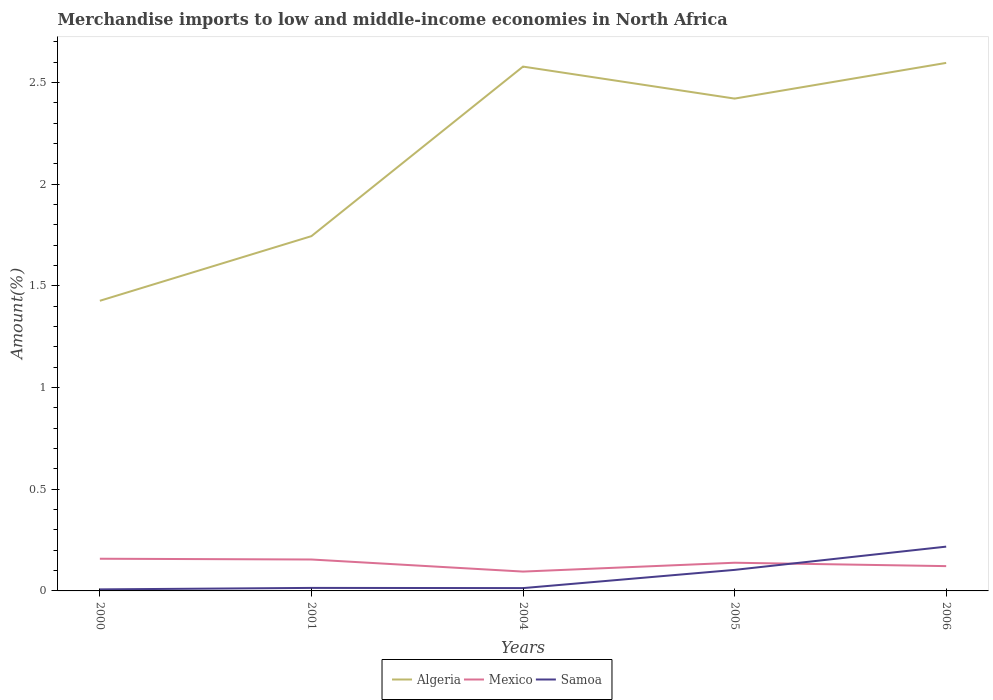Across all years, what is the maximum percentage of amount earned from merchandise imports in Samoa?
Keep it short and to the point. 0.01. In which year was the percentage of amount earned from merchandise imports in Algeria maximum?
Ensure brevity in your answer.  2000. What is the total percentage of amount earned from merchandise imports in Mexico in the graph?
Your answer should be very brief. 0.03. What is the difference between the highest and the second highest percentage of amount earned from merchandise imports in Algeria?
Provide a succinct answer. 1.17. What is the difference between the highest and the lowest percentage of amount earned from merchandise imports in Samoa?
Provide a succinct answer. 2. Is the percentage of amount earned from merchandise imports in Mexico strictly greater than the percentage of amount earned from merchandise imports in Algeria over the years?
Offer a terse response. Yes. How many lines are there?
Your answer should be compact. 3. How many years are there in the graph?
Provide a short and direct response. 5. Are the values on the major ticks of Y-axis written in scientific E-notation?
Your answer should be very brief. No. Does the graph contain any zero values?
Provide a short and direct response. No. How are the legend labels stacked?
Keep it short and to the point. Horizontal. What is the title of the graph?
Your answer should be compact. Merchandise imports to low and middle-income economies in North Africa. What is the label or title of the Y-axis?
Provide a succinct answer. Amount(%). What is the Amount(%) of Algeria in 2000?
Offer a very short reply. 1.43. What is the Amount(%) in Mexico in 2000?
Your response must be concise. 0.16. What is the Amount(%) of Samoa in 2000?
Make the answer very short. 0.01. What is the Amount(%) of Algeria in 2001?
Provide a succinct answer. 1.74. What is the Amount(%) in Mexico in 2001?
Give a very brief answer. 0.15. What is the Amount(%) of Samoa in 2001?
Keep it short and to the point. 0.01. What is the Amount(%) in Algeria in 2004?
Provide a short and direct response. 2.58. What is the Amount(%) in Mexico in 2004?
Offer a very short reply. 0.1. What is the Amount(%) of Samoa in 2004?
Provide a succinct answer. 0.01. What is the Amount(%) of Algeria in 2005?
Provide a succinct answer. 2.42. What is the Amount(%) in Mexico in 2005?
Offer a terse response. 0.14. What is the Amount(%) of Samoa in 2005?
Your answer should be compact. 0.1. What is the Amount(%) of Algeria in 2006?
Provide a short and direct response. 2.6. What is the Amount(%) in Mexico in 2006?
Provide a short and direct response. 0.12. What is the Amount(%) in Samoa in 2006?
Your response must be concise. 0.22. Across all years, what is the maximum Amount(%) of Algeria?
Offer a terse response. 2.6. Across all years, what is the maximum Amount(%) of Mexico?
Your response must be concise. 0.16. Across all years, what is the maximum Amount(%) in Samoa?
Your answer should be very brief. 0.22. Across all years, what is the minimum Amount(%) in Algeria?
Your response must be concise. 1.43. Across all years, what is the minimum Amount(%) of Mexico?
Your response must be concise. 0.1. Across all years, what is the minimum Amount(%) in Samoa?
Ensure brevity in your answer.  0.01. What is the total Amount(%) in Algeria in the graph?
Your answer should be compact. 10.77. What is the total Amount(%) of Mexico in the graph?
Offer a very short reply. 0.67. What is the total Amount(%) in Samoa in the graph?
Your answer should be compact. 0.36. What is the difference between the Amount(%) in Algeria in 2000 and that in 2001?
Give a very brief answer. -0.32. What is the difference between the Amount(%) of Mexico in 2000 and that in 2001?
Offer a terse response. 0. What is the difference between the Amount(%) of Samoa in 2000 and that in 2001?
Keep it short and to the point. -0.01. What is the difference between the Amount(%) in Algeria in 2000 and that in 2004?
Offer a terse response. -1.15. What is the difference between the Amount(%) of Mexico in 2000 and that in 2004?
Your answer should be compact. 0.06. What is the difference between the Amount(%) of Samoa in 2000 and that in 2004?
Your answer should be compact. -0.01. What is the difference between the Amount(%) in Algeria in 2000 and that in 2005?
Provide a short and direct response. -0.99. What is the difference between the Amount(%) of Mexico in 2000 and that in 2005?
Provide a short and direct response. 0.02. What is the difference between the Amount(%) in Samoa in 2000 and that in 2005?
Make the answer very short. -0.1. What is the difference between the Amount(%) of Algeria in 2000 and that in 2006?
Offer a terse response. -1.17. What is the difference between the Amount(%) of Mexico in 2000 and that in 2006?
Provide a succinct answer. 0.04. What is the difference between the Amount(%) in Samoa in 2000 and that in 2006?
Ensure brevity in your answer.  -0.21. What is the difference between the Amount(%) in Algeria in 2001 and that in 2004?
Provide a short and direct response. -0.83. What is the difference between the Amount(%) in Mexico in 2001 and that in 2004?
Make the answer very short. 0.06. What is the difference between the Amount(%) of Samoa in 2001 and that in 2004?
Offer a very short reply. 0. What is the difference between the Amount(%) of Algeria in 2001 and that in 2005?
Your response must be concise. -0.68. What is the difference between the Amount(%) in Mexico in 2001 and that in 2005?
Offer a terse response. 0.02. What is the difference between the Amount(%) in Samoa in 2001 and that in 2005?
Offer a very short reply. -0.09. What is the difference between the Amount(%) of Algeria in 2001 and that in 2006?
Keep it short and to the point. -0.85. What is the difference between the Amount(%) in Mexico in 2001 and that in 2006?
Offer a terse response. 0.03. What is the difference between the Amount(%) in Samoa in 2001 and that in 2006?
Provide a short and direct response. -0.2. What is the difference between the Amount(%) in Algeria in 2004 and that in 2005?
Provide a succinct answer. 0.16. What is the difference between the Amount(%) in Mexico in 2004 and that in 2005?
Keep it short and to the point. -0.04. What is the difference between the Amount(%) in Samoa in 2004 and that in 2005?
Provide a succinct answer. -0.09. What is the difference between the Amount(%) in Algeria in 2004 and that in 2006?
Your answer should be very brief. -0.02. What is the difference between the Amount(%) in Mexico in 2004 and that in 2006?
Offer a very short reply. -0.03. What is the difference between the Amount(%) in Samoa in 2004 and that in 2006?
Your response must be concise. -0.2. What is the difference between the Amount(%) in Algeria in 2005 and that in 2006?
Offer a very short reply. -0.18. What is the difference between the Amount(%) of Mexico in 2005 and that in 2006?
Make the answer very short. 0.02. What is the difference between the Amount(%) of Samoa in 2005 and that in 2006?
Offer a terse response. -0.11. What is the difference between the Amount(%) in Algeria in 2000 and the Amount(%) in Mexico in 2001?
Make the answer very short. 1.27. What is the difference between the Amount(%) of Algeria in 2000 and the Amount(%) of Samoa in 2001?
Your answer should be compact. 1.41. What is the difference between the Amount(%) of Mexico in 2000 and the Amount(%) of Samoa in 2001?
Provide a succinct answer. 0.14. What is the difference between the Amount(%) of Algeria in 2000 and the Amount(%) of Mexico in 2004?
Your answer should be very brief. 1.33. What is the difference between the Amount(%) of Algeria in 2000 and the Amount(%) of Samoa in 2004?
Your answer should be very brief. 1.41. What is the difference between the Amount(%) in Mexico in 2000 and the Amount(%) in Samoa in 2004?
Your answer should be very brief. 0.14. What is the difference between the Amount(%) in Algeria in 2000 and the Amount(%) in Mexico in 2005?
Offer a very short reply. 1.29. What is the difference between the Amount(%) of Algeria in 2000 and the Amount(%) of Samoa in 2005?
Your answer should be very brief. 1.32. What is the difference between the Amount(%) of Mexico in 2000 and the Amount(%) of Samoa in 2005?
Provide a succinct answer. 0.05. What is the difference between the Amount(%) of Algeria in 2000 and the Amount(%) of Mexico in 2006?
Offer a very short reply. 1.3. What is the difference between the Amount(%) in Algeria in 2000 and the Amount(%) in Samoa in 2006?
Provide a succinct answer. 1.21. What is the difference between the Amount(%) in Mexico in 2000 and the Amount(%) in Samoa in 2006?
Your answer should be very brief. -0.06. What is the difference between the Amount(%) of Algeria in 2001 and the Amount(%) of Mexico in 2004?
Offer a very short reply. 1.65. What is the difference between the Amount(%) of Algeria in 2001 and the Amount(%) of Samoa in 2004?
Your answer should be very brief. 1.73. What is the difference between the Amount(%) of Mexico in 2001 and the Amount(%) of Samoa in 2004?
Offer a terse response. 0.14. What is the difference between the Amount(%) of Algeria in 2001 and the Amount(%) of Mexico in 2005?
Offer a terse response. 1.61. What is the difference between the Amount(%) in Algeria in 2001 and the Amount(%) in Samoa in 2005?
Keep it short and to the point. 1.64. What is the difference between the Amount(%) of Mexico in 2001 and the Amount(%) of Samoa in 2005?
Give a very brief answer. 0.05. What is the difference between the Amount(%) in Algeria in 2001 and the Amount(%) in Mexico in 2006?
Offer a very short reply. 1.62. What is the difference between the Amount(%) in Algeria in 2001 and the Amount(%) in Samoa in 2006?
Offer a terse response. 1.53. What is the difference between the Amount(%) of Mexico in 2001 and the Amount(%) of Samoa in 2006?
Keep it short and to the point. -0.06. What is the difference between the Amount(%) in Algeria in 2004 and the Amount(%) in Mexico in 2005?
Your response must be concise. 2.44. What is the difference between the Amount(%) of Algeria in 2004 and the Amount(%) of Samoa in 2005?
Your answer should be compact. 2.47. What is the difference between the Amount(%) in Mexico in 2004 and the Amount(%) in Samoa in 2005?
Your response must be concise. -0.01. What is the difference between the Amount(%) in Algeria in 2004 and the Amount(%) in Mexico in 2006?
Your response must be concise. 2.46. What is the difference between the Amount(%) in Algeria in 2004 and the Amount(%) in Samoa in 2006?
Your response must be concise. 2.36. What is the difference between the Amount(%) in Mexico in 2004 and the Amount(%) in Samoa in 2006?
Give a very brief answer. -0.12. What is the difference between the Amount(%) of Algeria in 2005 and the Amount(%) of Mexico in 2006?
Ensure brevity in your answer.  2.3. What is the difference between the Amount(%) of Algeria in 2005 and the Amount(%) of Samoa in 2006?
Give a very brief answer. 2.2. What is the difference between the Amount(%) in Mexico in 2005 and the Amount(%) in Samoa in 2006?
Your response must be concise. -0.08. What is the average Amount(%) in Algeria per year?
Give a very brief answer. 2.15. What is the average Amount(%) in Mexico per year?
Your answer should be compact. 0.13. What is the average Amount(%) in Samoa per year?
Make the answer very short. 0.07. In the year 2000, what is the difference between the Amount(%) of Algeria and Amount(%) of Mexico?
Offer a very short reply. 1.27. In the year 2000, what is the difference between the Amount(%) in Algeria and Amount(%) in Samoa?
Keep it short and to the point. 1.42. In the year 2000, what is the difference between the Amount(%) of Mexico and Amount(%) of Samoa?
Your answer should be compact. 0.15. In the year 2001, what is the difference between the Amount(%) of Algeria and Amount(%) of Mexico?
Offer a very short reply. 1.59. In the year 2001, what is the difference between the Amount(%) in Algeria and Amount(%) in Samoa?
Provide a short and direct response. 1.73. In the year 2001, what is the difference between the Amount(%) in Mexico and Amount(%) in Samoa?
Offer a terse response. 0.14. In the year 2004, what is the difference between the Amount(%) in Algeria and Amount(%) in Mexico?
Your response must be concise. 2.48. In the year 2004, what is the difference between the Amount(%) of Algeria and Amount(%) of Samoa?
Provide a succinct answer. 2.56. In the year 2004, what is the difference between the Amount(%) of Mexico and Amount(%) of Samoa?
Your answer should be compact. 0.08. In the year 2005, what is the difference between the Amount(%) of Algeria and Amount(%) of Mexico?
Offer a terse response. 2.28. In the year 2005, what is the difference between the Amount(%) of Algeria and Amount(%) of Samoa?
Offer a terse response. 2.32. In the year 2005, what is the difference between the Amount(%) in Mexico and Amount(%) in Samoa?
Ensure brevity in your answer.  0.04. In the year 2006, what is the difference between the Amount(%) of Algeria and Amount(%) of Mexico?
Your answer should be very brief. 2.47. In the year 2006, what is the difference between the Amount(%) of Algeria and Amount(%) of Samoa?
Keep it short and to the point. 2.38. In the year 2006, what is the difference between the Amount(%) of Mexico and Amount(%) of Samoa?
Offer a terse response. -0.1. What is the ratio of the Amount(%) of Algeria in 2000 to that in 2001?
Your answer should be compact. 0.82. What is the ratio of the Amount(%) in Mexico in 2000 to that in 2001?
Your response must be concise. 1.02. What is the ratio of the Amount(%) in Samoa in 2000 to that in 2001?
Give a very brief answer. 0.52. What is the ratio of the Amount(%) in Algeria in 2000 to that in 2004?
Provide a short and direct response. 0.55. What is the ratio of the Amount(%) in Mexico in 2000 to that in 2004?
Ensure brevity in your answer.  1.66. What is the ratio of the Amount(%) of Samoa in 2000 to that in 2004?
Keep it short and to the point. 0.55. What is the ratio of the Amount(%) in Algeria in 2000 to that in 2005?
Ensure brevity in your answer.  0.59. What is the ratio of the Amount(%) of Mexico in 2000 to that in 2005?
Give a very brief answer. 1.14. What is the ratio of the Amount(%) of Samoa in 2000 to that in 2005?
Provide a short and direct response. 0.07. What is the ratio of the Amount(%) of Algeria in 2000 to that in 2006?
Provide a succinct answer. 0.55. What is the ratio of the Amount(%) in Mexico in 2000 to that in 2006?
Your answer should be very brief. 1.3. What is the ratio of the Amount(%) of Samoa in 2000 to that in 2006?
Ensure brevity in your answer.  0.04. What is the ratio of the Amount(%) in Algeria in 2001 to that in 2004?
Make the answer very short. 0.68. What is the ratio of the Amount(%) in Mexico in 2001 to that in 2004?
Offer a terse response. 1.62. What is the ratio of the Amount(%) in Samoa in 2001 to that in 2004?
Offer a very short reply. 1.07. What is the ratio of the Amount(%) of Algeria in 2001 to that in 2005?
Your answer should be compact. 0.72. What is the ratio of the Amount(%) of Mexico in 2001 to that in 2005?
Your answer should be compact. 1.11. What is the ratio of the Amount(%) of Samoa in 2001 to that in 2005?
Provide a short and direct response. 0.14. What is the ratio of the Amount(%) of Algeria in 2001 to that in 2006?
Your response must be concise. 0.67. What is the ratio of the Amount(%) in Mexico in 2001 to that in 2006?
Provide a succinct answer. 1.27. What is the ratio of the Amount(%) of Samoa in 2001 to that in 2006?
Your response must be concise. 0.07. What is the ratio of the Amount(%) in Algeria in 2004 to that in 2005?
Give a very brief answer. 1.06. What is the ratio of the Amount(%) of Mexico in 2004 to that in 2005?
Give a very brief answer. 0.69. What is the ratio of the Amount(%) in Samoa in 2004 to that in 2005?
Keep it short and to the point. 0.13. What is the ratio of the Amount(%) of Mexico in 2004 to that in 2006?
Make the answer very short. 0.78. What is the ratio of the Amount(%) in Samoa in 2004 to that in 2006?
Make the answer very short. 0.06. What is the ratio of the Amount(%) in Algeria in 2005 to that in 2006?
Ensure brevity in your answer.  0.93. What is the ratio of the Amount(%) in Mexico in 2005 to that in 2006?
Ensure brevity in your answer.  1.14. What is the ratio of the Amount(%) of Samoa in 2005 to that in 2006?
Your answer should be very brief. 0.48. What is the difference between the highest and the second highest Amount(%) of Algeria?
Keep it short and to the point. 0.02. What is the difference between the highest and the second highest Amount(%) in Mexico?
Give a very brief answer. 0. What is the difference between the highest and the second highest Amount(%) in Samoa?
Offer a very short reply. 0.11. What is the difference between the highest and the lowest Amount(%) in Algeria?
Ensure brevity in your answer.  1.17. What is the difference between the highest and the lowest Amount(%) in Mexico?
Provide a short and direct response. 0.06. What is the difference between the highest and the lowest Amount(%) in Samoa?
Your answer should be very brief. 0.21. 